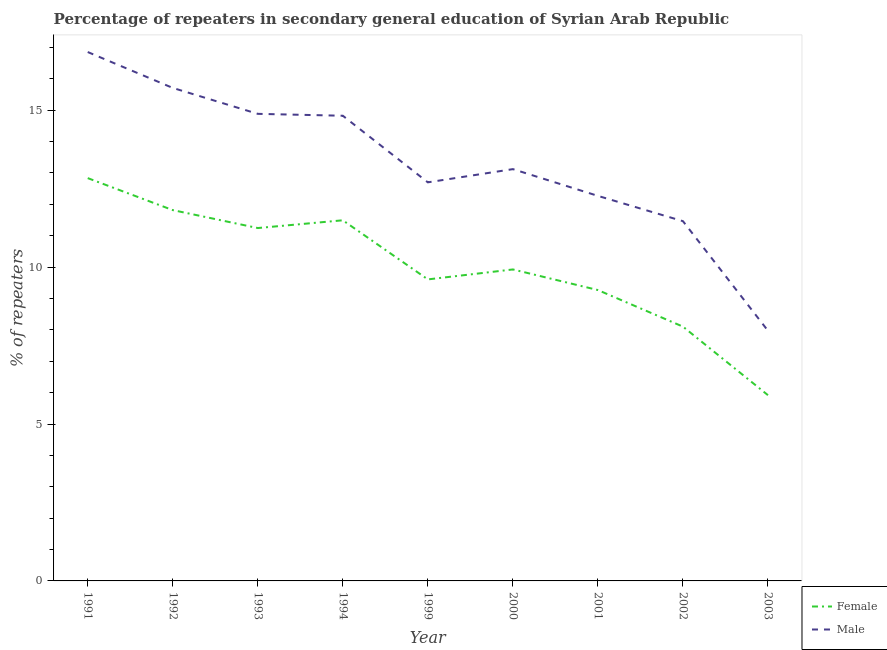Is the number of lines equal to the number of legend labels?
Make the answer very short. Yes. What is the percentage of male repeaters in 2001?
Give a very brief answer. 12.27. Across all years, what is the maximum percentage of male repeaters?
Provide a succinct answer. 16.85. Across all years, what is the minimum percentage of male repeaters?
Provide a succinct answer. 7.97. In which year was the percentage of male repeaters maximum?
Your answer should be very brief. 1991. What is the total percentage of male repeaters in the graph?
Make the answer very short. 119.8. What is the difference between the percentage of male repeaters in 1992 and that in 1994?
Your answer should be very brief. 0.89. What is the difference between the percentage of male repeaters in 1994 and the percentage of female repeaters in 2000?
Offer a terse response. 4.9. What is the average percentage of female repeaters per year?
Your answer should be compact. 10.02. In the year 2003, what is the difference between the percentage of female repeaters and percentage of male repeaters?
Make the answer very short. -2.05. What is the ratio of the percentage of female repeaters in 1999 to that in 2000?
Make the answer very short. 0.97. Is the difference between the percentage of male repeaters in 1993 and 1999 greater than the difference between the percentage of female repeaters in 1993 and 1999?
Provide a succinct answer. Yes. What is the difference between the highest and the second highest percentage of female repeaters?
Ensure brevity in your answer.  1.02. What is the difference between the highest and the lowest percentage of male repeaters?
Ensure brevity in your answer.  8.88. Is the sum of the percentage of female repeaters in 1992 and 1994 greater than the maximum percentage of male repeaters across all years?
Offer a very short reply. Yes. Is the percentage of male repeaters strictly greater than the percentage of female repeaters over the years?
Provide a succinct answer. Yes. How many lines are there?
Ensure brevity in your answer.  2. How many years are there in the graph?
Your answer should be compact. 9. What is the title of the graph?
Your answer should be compact. Percentage of repeaters in secondary general education of Syrian Arab Republic. Does "Number of departures" appear as one of the legend labels in the graph?
Provide a succinct answer. No. What is the label or title of the X-axis?
Your answer should be very brief. Year. What is the label or title of the Y-axis?
Keep it short and to the point. % of repeaters. What is the % of repeaters in Female in 1991?
Provide a short and direct response. 12.84. What is the % of repeaters in Male in 1991?
Ensure brevity in your answer.  16.85. What is the % of repeaters in Female in 1992?
Offer a very short reply. 11.82. What is the % of repeaters in Male in 1992?
Provide a succinct answer. 15.71. What is the % of repeaters of Female in 1993?
Offer a very short reply. 11.24. What is the % of repeaters of Male in 1993?
Your answer should be compact. 14.88. What is the % of repeaters in Female in 1994?
Provide a succinct answer. 11.49. What is the % of repeaters of Male in 1994?
Your answer should be very brief. 14.82. What is the % of repeaters of Female in 1999?
Your answer should be compact. 9.61. What is the % of repeaters of Male in 1999?
Offer a terse response. 12.7. What is the % of repeaters in Female in 2000?
Offer a very short reply. 9.93. What is the % of repeaters of Male in 2000?
Offer a very short reply. 13.12. What is the % of repeaters of Female in 2001?
Your answer should be compact. 9.27. What is the % of repeaters of Male in 2001?
Your answer should be compact. 12.27. What is the % of repeaters in Female in 2002?
Your response must be concise. 8.1. What is the % of repeaters of Male in 2002?
Keep it short and to the point. 11.46. What is the % of repeaters of Female in 2003?
Provide a short and direct response. 5.92. What is the % of repeaters in Male in 2003?
Offer a terse response. 7.97. Across all years, what is the maximum % of repeaters of Female?
Provide a short and direct response. 12.84. Across all years, what is the maximum % of repeaters of Male?
Keep it short and to the point. 16.85. Across all years, what is the minimum % of repeaters of Female?
Your answer should be very brief. 5.92. Across all years, what is the minimum % of repeaters of Male?
Offer a very short reply. 7.97. What is the total % of repeaters of Female in the graph?
Your answer should be very brief. 90.21. What is the total % of repeaters of Male in the graph?
Your response must be concise. 119.8. What is the difference between the % of repeaters of Female in 1991 and that in 1992?
Provide a short and direct response. 1.02. What is the difference between the % of repeaters in Male in 1991 and that in 1992?
Make the answer very short. 1.14. What is the difference between the % of repeaters in Female in 1991 and that in 1993?
Provide a succinct answer. 1.59. What is the difference between the % of repeaters of Male in 1991 and that in 1993?
Give a very brief answer. 1.97. What is the difference between the % of repeaters of Female in 1991 and that in 1994?
Your response must be concise. 1.34. What is the difference between the % of repeaters in Male in 1991 and that in 1994?
Give a very brief answer. 2.03. What is the difference between the % of repeaters in Female in 1991 and that in 1999?
Keep it short and to the point. 3.23. What is the difference between the % of repeaters in Male in 1991 and that in 1999?
Offer a very short reply. 4.15. What is the difference between the % of repeaters of Female in 1991 and that in 2000?
Provide a short and direct response. 2.91. What is the difference between the % of repeaters in Male in 1991 and that in 2000?
Your answer should be very brief. 3.73. What is the difference between the % of repeaters in Female in 1991 and that in 2001?
Your response must be concise. 3.57. What is the difference between the % of repeaters of Male in 1991 and that in 2001?
Offer a very short reply. 4.58. What is the difference between the % of repeaters in Female in 1991 and that in 2002?
Your answer should be compact. 4.73. What is the difference between the % of repeaters in Male in 1991 and that in 2002?
Your answer should be compact. 5.39. What is the difference between the % of repeaters in Female in 1991 and that in 2003?
Provide a succinct answer. 6.92. What is the difference between the % of repeaters in Male in 1991 and that in 2003?
Offer a terse response. 8.88. What is the difference between the % of repeaters of Female in 1992 and that in 1993?
Provide a short and direct response. 0.57. What is the difference between the % of repeaters in Male in 1992 and that in 1993?
Your response must be concise. 0.83. What is the difference between the % of repeaters in Female in 1992 and that in 1994?
Your answer should be very brief. 0.32. What is the difference between the % of repeaters in Male in 1992 and that in 1994?
Give a very brief answer. 0.89. What is the difference between the % of repeaters of Female in 1992 and that in 1999?
Give a very brief answer. 2.21. What is the difference between the % of repeaters of Male in 1992 and that in 1999?
Keep it short and to the point. 3.01. What is the difference between the % of repeaters in Female in 1992 and that in 2000?
Keep it short and to the point. 1.89. What is the difference between the % of repeaters in Male in 1992 and that in 2000?
Offer a very short reply. 2.59. What is the difference between the % of repeaters in Female in 1992 and that in 2001?
Give a very brief answer. 2.55. What is the difference between the % of repeaters of Male in 1992 and that in 2001?
Keep it short and to the point. 3.44. What is the difference between the % of repeaters of Female in 1992 and that in 2002?
Your response must be concise. 3.71. What is the difference between the % of repeaters of Male in 1992 and that in 2002?
Provide a short and direct response. 4.25. What is the difference between the % of repeaters of Female in 1992 and that in 2003?
Your answer should be very brief. 5.9. What is the difference between the % of repeaters in Male in 1992 and that in 2003?
Keep it short and to the point. 7.74. What is the difference between the % of repeaters in Female in 1993 and that in 1994?
Your answer should be compact. -0.25. What is the difference between the % of repeaters in Male in 1993 and that in 1994?
Offer a very short reply. 0.06. What is the difference between the % of repeaters of Female in 1993 and that in 1999?
Provide a succinct answer. 1.64. What is the difference between the % of repeaters of Male in 1993 and that in 1999?
Keep it short and to the point. 2.18. What is the difference between the % of repeaters of Female in 1993 and that in 2000?
Provide a succinct answer. 1.32. What is the difference between the % of repeaters in Male in 1993 and that in 2000?
Provide a short and direct response. 1.76. What is the difference between the % of repeaters of Female in 1993 and that in 2001?
Keep it short and to the point. 1.98. What is the difference between the % of repeaters in Male in 1993 and that in 2001?
Ensure brevity in your answer.  2.61. What is the difference between the % of repeaters of Female in 1993 and that in 2002?
Your answer should be very brief. 3.14. What is the difference between the % of repeaters in Male in 1993 and that in 2002?
Provide a short and direct response. 3.42. What is the difference between the % of repeaters of Female in 1993 and that in 2003?
Keep it short and to the point. 5.33. What is the difference between the % of repeaters in Male in 1993 and that in 2003?
Provide a short and direct response. 6.91. What is the difference between the % of repeaters of Female in 1994 and that in 1999?
Give a very brief answer. 1.88. What is the difference between the % of repeaters in Male in 1994 and that in 1999?
Ensure brevity in your answer.  2.12. What is the difference between the % of repeaters of Female in 1994 and that in 2000?
Your response must be concise. 1.57. What is the difference between the % of repeaters of Male in 1994 and that in 2000?
Provide a succinct answer. 1.7. What is the difference between the % of repeaters in Female in 1994 and that in 2001?
Offer a very short reply. 2.22. What is the difference between the % of repeaters of Male in 1994 and that in 2001?
Make the answer very short. 2.55. What is the difference between the % of repeaters in Female in 1994 and that in 2002?
Make the answer very short. 3.39. What is the difference between the % of repeaters of Male in 1994 and that in 2002?
Ensure brevity in your answer.  3.36. What is the difference between the % of repeaters in Female in 1994 and that in 2003?
Give a very brief answer. 5.57. What is the difference between the % of repeaters in Male in 1994 and that in 2003?
Offer a very short reply. 6.85. What is the difference between the % of repeaters of Female in 1999 and that in 2000?
Give a very brief answer. -0.32. What is the difference between the % of repeaters in Male in 1999 and that in 2000?
Your answer should be very brief. -0.42. What is the difference between the % of repeaters of Female in 1999 and that in 2001?
Give a very brief answer. 0.34. What is the difference between the % of repeaters of Male in 1999 and that in 2001?
Keep it short and to the point. 0.43. What is the difference between the % of repeaters in Female in 1999 and that in 2002?
Ensure brevity in your answer.  1.5. What is the difference between the % of repeaters of Male in 1999 and that in 2002?
Provide a succinct answer. 1.24. What is the difference between the % of repeaters in Female in 1999 and that in 2003?
Your answer should be very brief. 3.69. What is the difference between the % of repeaters in Male in 1999 and that in 2003?
Your response must be concise. 4.73. What is the difference between the % of repeaters in Female in 2000 and that in 2001?
Offer a terse response. 0.66. What is the difference between the % of repeaters of Male in 2000 and that in 2001?
Offer a very short reply. 0.85. What is the difference between the % of repeaters in Female in 2000 and that in 2002?
Provide a short and direct response. 1.82. What is the difference between the % of repeaters of Male in 2000 and that in 2002?
Ensure brevity in your answer.  1.66. What is the difference between the % of repeaters of Female in 2000 and that in 2003?
Your response must be concise. 4.01. What is the difference between the % of repeaters in Male in 2000 and that in 2003?
Give a very brief answer. 5.15. What is the difference between the % of repeaters of Female in 2001 and that in 2002?
Ensure brevity in your answer.  1.17. What is the difference between the % of repeaters in Male in 2001 and that in 2002?
Your response must be concise. 0.81. What is the difference between the % of repeaters in Female in 2001 and that in 2003?
Offer a terse response. 3.35. What is the difference between the % of repeaters of Male in 2001 and that in 2003?
Give a very brief answer. 4.3. What is the difference between the % of repeaters of Female in 2002 and that in 2003?
Make the answer very short. 2.18. What is the difference between the % of repeaters of Male in 2002 and that in 2003?
Give a very brief answer. 3.49. What is the difference between the % of repeaters of Female in 1991 and the % of repeaters of Male in 1992?
Keep it short and to the point. -2.87. What is the difference between the % of repeaters of Female in 1991 and the % of repeaters of Male in 1993?
Provide a succinct answer. -2.05. What is the difference between the % of repeaters of Female in 1991 and the % of repeaters of Male in 1994?
Your response must be concise. -1.99. What is the difference between the % of repeaters of Female in 1991 and the % of repeaters of Male in 1999?
Make the answer very short. 0.13. What is the difference between the % of repeaters of Female in 1991 and the % of repeaters of Male in 2000?
Ensure brevity in your answer.  -0.29. What is the difference between the % of repeaters of Female in 1991 and the % of repeaters of Male in 2001?
Provide a short and direct response. 0.57. What is the difference between the % of repeaters in Female in 1991 and the % of repeaters in Male in 2002?
Keep it short and to the point. 1.37. What is the difference between the % of repeaters of Female in 1991 and the % of repeaters of Male in 2003?
Offer a very short reply. 4.86. What is the difference between the % of repeaters of Female in 1992 and the % of repeaters of Male in 1993?
Provide a succinct answer. -3.07. What is the difference between the % of repeaters in Female in 1992 and the % of repeaters in Male in 1994?
Make the answer very short. -3.01. What is the difference between the % of repeaters of Female in 1992 and the % of repeaters of Male in 1999?
Offer a very short reply. -0.88. What is the difference between the % of repeaters of Female in 1992 and the % of repeaters of Male in 2000?
Offer a terse response. -1.31. What is the difference between the % of repeaters in Female in 1992 and the % of repeaters in Male in 2001?
Make the answer very short. -0.45. What is the difference between the % of repeaters of Female in 1992 and the % of repeaters of Male in 2002?
Your answer should be compact. 0.35. What is the difference between the % of repeaters of Female in 1992 and the % of repeaters of Male in 2003?
Keep it short and to the point. 3.84. What is the difference between the % of repeaters of Female in 1993 and the % of repeaters of Male in 1994?
Your answer should be very brief. -3.58. What is the difference between the % of repeaters in Female in 1993 and the % of repeaters in Male in 1999?
Offer a very short reply. -1.46. What is the difference between the % of repeaters of Female in 1993 and the % of repeaters of Male in 2000?
Keep it short and to the point. -1.88. What is the difference between the % of repeaters in Female in 1993 and the % of repeaters in Male in 2001?
Offer a terse response. -1.02. What is the difference between the % of repeaters of Female in 1993 and the % of repeaters of Male in 2002?
Offer a very short reply. -0.22. What is the difference between the % of repeaters of Female in 1993 and the % of repeaters of Male in 2003?
Offer a terse response. 3.27. What is the difference between the % of repeaters of Female in 1994 and the % of repeaters of Male in 1999?
Provide a succinct answer. -1.21. What is the difference between the % of repeaters of Female in 1994 and the % of repeaters of Male in 2000?
Your response must be concise. -1.63. What is the difference between the % of repeaters in Female in 1994 and the % of repeaters in Male in 2001?
Give a very brief answer. -0.78. What is the difference between the % of repeaters in Female in 1994 and the % of repeaters in Male in 2002?
Your answer should be compact. 0.03. What is the difference between the % of repeaters in Female in 1994 and the % of repeaters in Male in 2003?
Your response must be concise. 3.52. What is the difference between the % of repeaters in Female in 1999 and the % of repeaters in Male in 2000?
Provide a short and direct response. -3.51. What is the difference between the % of repeaters of Female in 1999 and the % of repeaters of Male in 2001?
Provide a succinct answer. -2.66. What is the difference between the % of repeaters of Female in 1999 and the % of repeaters of Male in 2002?
Offer a very short reply. -1.86. What is the difference between the % of repeaters in Female in 1999 and the % of repeaters in Male in 2003?
Your answer should be very brief. 1.64. What is the difference between the % of repeaters of Female in 2000 and the % of repeaters of Male in 2001?
Your answer should be compact. -2.34. What is the difference between the % of repeaters in Female in 2000 and the % of repeaters in Male in 2002?
Ensure brevity in your answer.  -1.54. What is the difference between the % of repeaters in Female in 2000 and the % of repeaters in Male in 2003?
Your answer should be compact. 1.95. What is the difference between the % of repeaters in Female in 2001 and the % of repeaters in Male in 2002?
Provide a short and direct response. -2.19. What is the difference between the % of repeaters in Female in 2001 and the % of repeaters in Male in 2003?
Give a very brief answer. 1.3. What is the difference between the % of repeaters in Female in 2002 and the % of repeaters in Male in 2003?
Offer a very short reply. 0.13. What is the average % of repeaters of Female per year?
Keep it short and to the point. 10.02. What is the average % of repeaters of Male per year?
Provide a succinct answer. 13.31. In the year 1991, what is the difference between the % of repeaters in Female and % of repeaters in Male?
Give a very brief answer. -4.02. In the year 1992, what is the difference between the % of repeaters in Female and % of repeaters in Male?
Provide a short and direct response. -3.89. In the year 1993, what is the difference between the % of repeaters in Female and % of repeaters in Male?
Your answer should be very brief. -3.64. In the year 1994, what is the difference between the % of repeaters in Female and % of repeaters in Male?
Your response must be concise. -3.33. In the year 1999, what is the difference between the % of repeaters of Female and % of repeaters of Male?
Provide a succinct answer. -3.09. In the year 2000, what is the difference between the % of repeaters of Female and % of repeaters of Male?
Offer a very short reply. -3.2. In the year 2001, what is the difference between the % of repeaters of Female and % of repeaters of Male?
Your response must be concise. -3. In the year 2002, what is the difference between the % of repeaters in Female and % of repeaters in Male?
Your answer should be compact. -3.36. In the year 2003, what is the difference between the % of repeaters of Female and % of repeaters of Male?
Provide a succinct answer. -2.05. What is the ratio of the % of repeaters in Female in 1991 to that in 1992?
Your answer should be very brief. 1.09. What is the ratio of the % of repeaters in Male in 1991 to that in 1992?
Make the answer very short. 1.07. What is the ratio of the % of repeaters in Female in 1991 to that in 1993?
Provide a short and direct response. 1.14. What is the ratio of the % of repeaters in Male in 1991 to that in 1993?
Your answer should be compact. 1.13. What is the ratio of the % of repeaters of Female in 1991 to that in 1994?
Provide a short and direct response. 1.12. What is the ratio of the % of repeaters in Male in 1991 to that in 1994?
Your answer should be very brief. 1.14. What is the ratio of the % of repeaters in Female in 1991 to that in 1999?
Your answer should be very brief. 1.34. What is the ratio of the % of repeaters in Male in 1991 to that in 1999?
Give a very brief answer. 1.33. What is the ratio of the % of repeaters in Female in 1991 to that in 2000?
Provide a succinct answer. 1.29. What is the ratio of the % of repeaters of Male in 1991 to that in 2000?
Provide a short and direct response. 1.28. What is the ratio of the % of repeaters in Female in 1991 to that in 2001?
Your answer should be compact. 1.38. What is the ratio of the % of repeaters in Male in 1991 to that in 2001?
Keep it short and to the point. 1.37. What is the ratio of the % of repeaters in Female in 1991 to that in 2002?
Your answer should be compact. 1.58. What is the ratio of the % of repeaters in Male in 1991 to that in 2002?
Offer a terse response. 1.47. What is the ratio of the % of repeaters in Female in 1991 to that in 2003?
Offer a very short reply. 2.17. What is the ratio of the % of repeaters in Male in 1991 to that in 2003?
Your answer should be very brief. 2.11. What is the ratio of the % of repeaters in Female in 1992 to that in 1993?
Offer a terse response. 1.05. What is the ratio of the % of repeaters in Male in 1992 to that in 1993?
Keep it short and to the point. 1.06. What is the ratio of the % of repeaters in Female in 1992 to that in 1994?
Your answer should be compact. 1.03. What is the ratio of the % of repeaters of Male in 1992 to that in 1994?
Your answer should be compact. 1.06. What is the ratio of the % of repeaters of Female in 1992 to that in 1999?
Give a very brief answer. 1.23. What is the ratio of the % of repeaters in Male in 1992 to that in 1999?
Your response must be concise. 1.24. What is the ratio of the % of repeaters of Female in 1992 to that in 2000?
Your answer should be very brief. 1.19. What is the ratio of the % of repeaters of Male in 1992 to that in 2000?
Provide a succinct answer. 1.2. What is the ratio of the % of repeaters of Female in 1992 to that in 2001?
Ensure brevity in your answer.  1.27. What is the ratio of the % of repeaters of Male in 1992 to that in 2001?
Keep it short and to the point. 1.28. What is the ratio of the % of repeaters in Female in 1992 to that in 2002?
Offer a very short reply. 1.46. What is the ratio of the % of repeaters of Male in 1992 to that in 2002?
Give a very brief answer. 1.37. What is the ratio of the % of repeaters in Female in 1992 to that in 2003?
Your response must be concise. 2. What is the ratio of the % of repeaters in Male in 1992 to that in 2003?
Ensure brevity in your answer.  1.97. What is the ratio of the % of repeaters in Female in 1993 to that in 1994?
Your answer should be compact. 0.98. What is the ratio of the % of repeaters of Male in 1993 to that in 1994?
Offer a terse response. 1. What is the ratio of the % of repeaters of Female in 1993 to that in 1999?
Offer a terse response. 1.17. What is the ratio of the % of repeaters of Male in 1993 to that in 1999?
Your response must be concise. 1.17. What is the ratio of the % of repeaters in Female in 1993 to that in 2000?
Offer a very short reply. 1.13. What is the ratio of the % of repeaters of Male in 1993 to that in 2000?
Keep it short and to the point. 1.13. What is the ratio of the % of repeaters of Female in 1993 to that in 2001?
Keep it short and to the point. 1.21. What is the ratio of the % of repeaters in Male in 1993 to that in 2001?
Provide a short and direct response. 1.21. What is the ratio of the % of repeaters of Female in 1993 to that in 2002?
Provide a short and direct response. 1.39. What is the ratio of the % of repeaters in Male in 1993 to that in 2002?
Your answer should be compact. 1.3. What is the ratio of the % of repeaters in Female in 1993 to that in 2003?
Offer a very short reply. 1.9. What is the ratio of the % of repeaters of Male in 1993 to that in 2003?
Your response must be concise. 1.87. What is the ratio of the % of repeaters of Female in 1994 to that in 1999?
Your answer should be very brief. 1.2. What is the ratio of the % of repeaters of Male in 1994 to that in 1999?
Offer a very short reply. 1.17. What is the ratio of the % of repeaters of Female in 1994 to that in 2000?
Make the answer very short. 1.16. What is the ratio of the % of repeaters in Male in 1994 to that in 2000?
Keep it short and to the point. 1.13. What is the ratio of the % of repeaters in Female in 1994 to that in 2001?
Your answer should be compact. 1.24. What is the ratio of the % of repeaters of Male in 1994 to that in 2001?
Keep it short and to the point. 1.21. What is the ratio of the % of repeaters of Female in 1994 to that in 2002?
Your response must be concise. 1.42. What is the ratio of the % of repeaters of Male in 1994 to that in 2002?
Keep it short and to the point. 1.29. What is the ratio of the % of repeaters of Female in 1994 to that in 2003?
Ensure brevity in your answer.  1.94. What is the ratio of the % of repeaters in Male in 1994 to that in 2003?
Your answer should be very brief. 1.86. What is the ratio of the % of repeaters of Female in 1999 to that in 2000?
Keep it short and to the point. 0.97. What is the ratio of the % of repeaters of Male in 1999 to that in 2000?
Your answer should be compact. 0.97. What is the ratio of the % of repeaters of Female in 1999 to that in 2001?
Your answer should be very brief. 1.04. What is the ratio of the % of repeaters of Male in 1999 to that in 2001?
Provide a short and direct response. 1.04. What is the ratio of the % of repeaters of Female in 1999 to that in 2002?
Keep it short and to the point. 1.19. What is the ratio of the % of repeaters of Male in 1999 to that in 2002?
Provide a short and direct response. 1.11. What is the ratio of the % of repeaters in Female in 1999 to that in 2003?
Give a very brief answer. 1.62. What is the ratio of the % of repeaters in Male in 1999 to that in 2003?
Your answer should be very brief. 1.59. What is the ratio of the % of repeaters of Female in 2000 to that in 2001?
Offer a terse response. 1.07. What is the ratio of the % of repeaters in Male in 2000 to that in 2001?
Provide a succinct answer. 1.07. What is the ratio of the % of repeaters in Female in 2000 to that in 2002?
Your response must be concise. 1.22. What is the ratio of the % of repeaters in Male in 2000 to that in 2002?
Give a very brief answer. 1.14. What is the ratio of the % of repeaters of Female in 2000 to that in 2003?
Offer a very short reply. 1.68. What is the ratio of the % of repeaters in Male in 2000 to that in 2003?
Offer a very short reply. 1.65. What is the ratio of the % of repeaters in Female in 2001 to that in 2002?
Ensure brevity in your answer.  1.14. What is the ratio of the % of repeaters of Male in 2001 to that in 2002?
Ensure brevity in your answer.  1.07. What is the ratio of the % of repeaters of Female in 2001 to that in 2003?
Provide a succinct answer. 1.57. What is the ratio of the % of repeaters in Male in 2001 to that in 2003?
Provide a short and direct response. 1.54. What is the ratio of the % of repeaters in Female in 2002 to that in 2003?
Your response must be concise. 1.37. What is the ratio of the % of repeaters of Male in 2002 to that in 2003?
Your answer should be very brief. 1.44. What is the difference between the highest and the second highest % of repeaters of Female?
Ensure brevity in your answer.  1.02. What is the difference between the highest and the second highest % of repeaters in Male?
Keep it short and to the point. 1.14. What is the difference between the highest and the lowest % of repeaters in Female?
Your answer should be very brief. 6.92. What is the difference between the highest and the lowest % of repeaters of Male?
Make the answer very short. 8.88. 